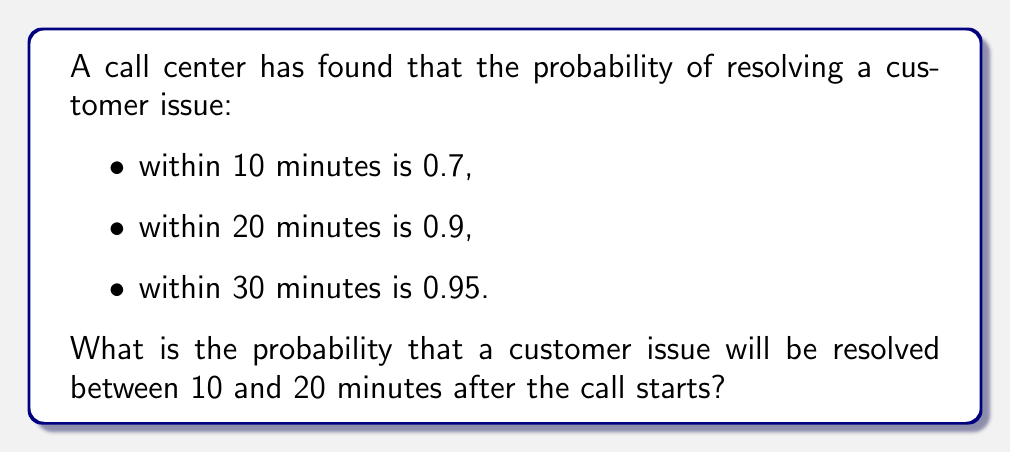What is the answer to this math problem? Let's approach this step-by-step:

1) Let's define our events:
   $A$ = issue resolved within 10 minutes
   $B$ = issue resolved within 20 minutes
   $C$ = issue resolved between 10 and 20 minutes

2) We're given:
   $P(A) = 0.7$
   $P(B) = 0.9$

3) We need to find $P(C)$. This is equivalent to the probability of the issue being resolved within 20 minutes, minus the probability of it being resolved within 10 minutes:

   $P(C) = P(B) - P(A)$

4) Substituting the values:

   $P(C) = 0.9 - 0.7$

5) Calculating:

   $P(C) = 0.2$

Therefore, the probability that a customer issue will be resolved between 10 and 20 minutes after the call starts is 0.2 or 20%.
Answer: $0.2$ or $20\%$ 